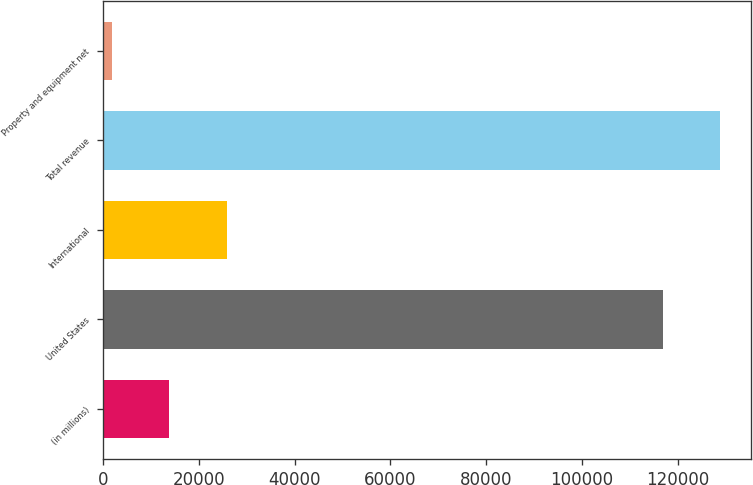<chart> <loc_0><loc_0><loc_500><loc_500><bar_chart><fcel>(in millions)<fcel>United States<fcel>International<fcel>Total revenue<fcel>Property and equipment net<nl><fcel>13771<fcel>116864<fcel>25746<fcel>128839<fcel>1796<nl></chart> 